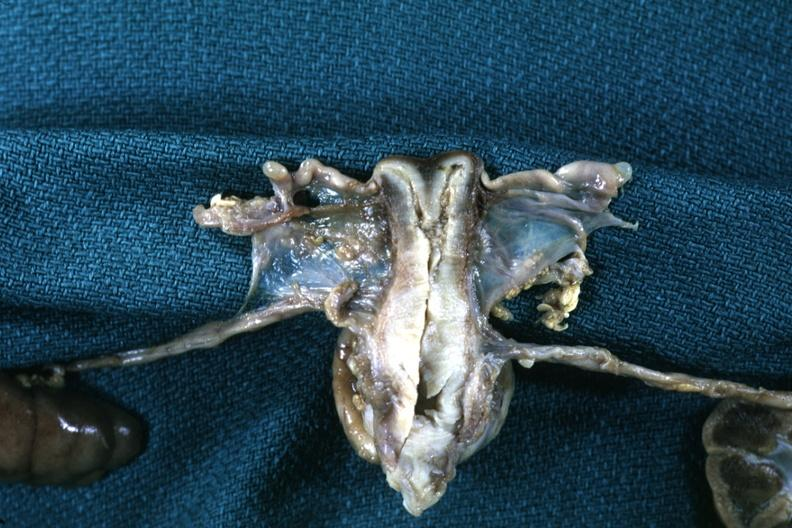what does this image show?
Answer the question using a single word or phrase. Fixed tissue frontal section through uterus with single fundus and two endocervical canals and cervical ossa 